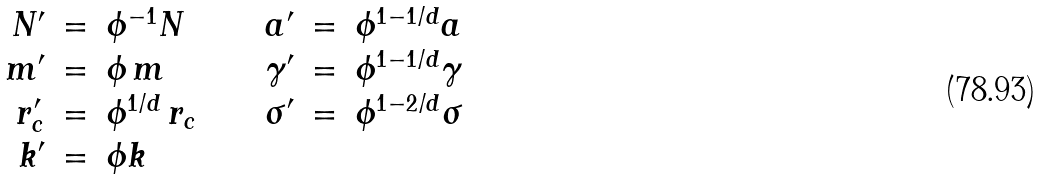<formula> <loc_0><loc_0><loc_500><loc_500>\begin{array} { r c l c r c l } N ^ { \prime } & = & \phi ^ { - 1 } N & \quad & a ^ { \prime } & = & \phi ^ { 1 - 1 / d } a \\ m ^ { \prime } & = & \phi \, m & \quad & \gamma ^ { \prime } & = & \phi ^ { 1 - 1 / d } \gamma \\ r _ { c } ^ { \prime } & = & \phi ^ { 1 / d } \, r _ { c } & \quad & \sigma ^ { \prime } & = & \phi ^ { 1 - 2 / d } \sigma \\ k ^ { \prime } & = & \phi k \end{array}</formula> 